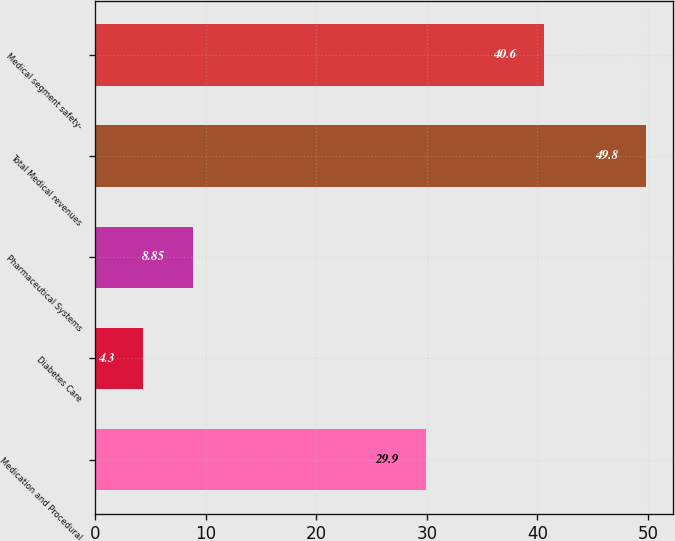Convert chart. <chart><loc_0><loc_0><loc_500><loc_500><bar_chart><fcel>Medication and Procedural<fcel>Diabetes Care<fcel>Pharmaceutical Systems<fcel>Total Medical revenues<fcel>Medical segment safety-<nl><fcel>29.9<fcel>4.3<fcel>8.85<fcel>49.8<fcel>40.6<nl></chart> 